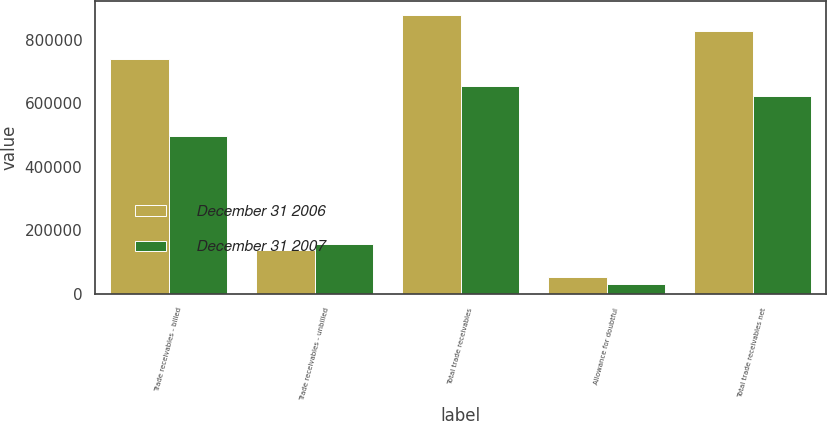Convert chart. <chart><loc_0><loc_0><loc_500><loc_500><stacked_bar_chart><ecel><fcel>Trade receivables - billed<fcel>Trade receivables - unbilled<fcel>Total trade receivables<fcel>Allowance for doubtful<fcel>Total trade receivables net<nl><fcel>December 31 2006<fcel>739504<fcel>139815<fcel>879319<fcel>53404<fcel>825915<nl><fcel>December 31 2007<fcel>496837<fcel>157680<fcel>654517<fcel>31452<fcel>623065<nl></chart> 